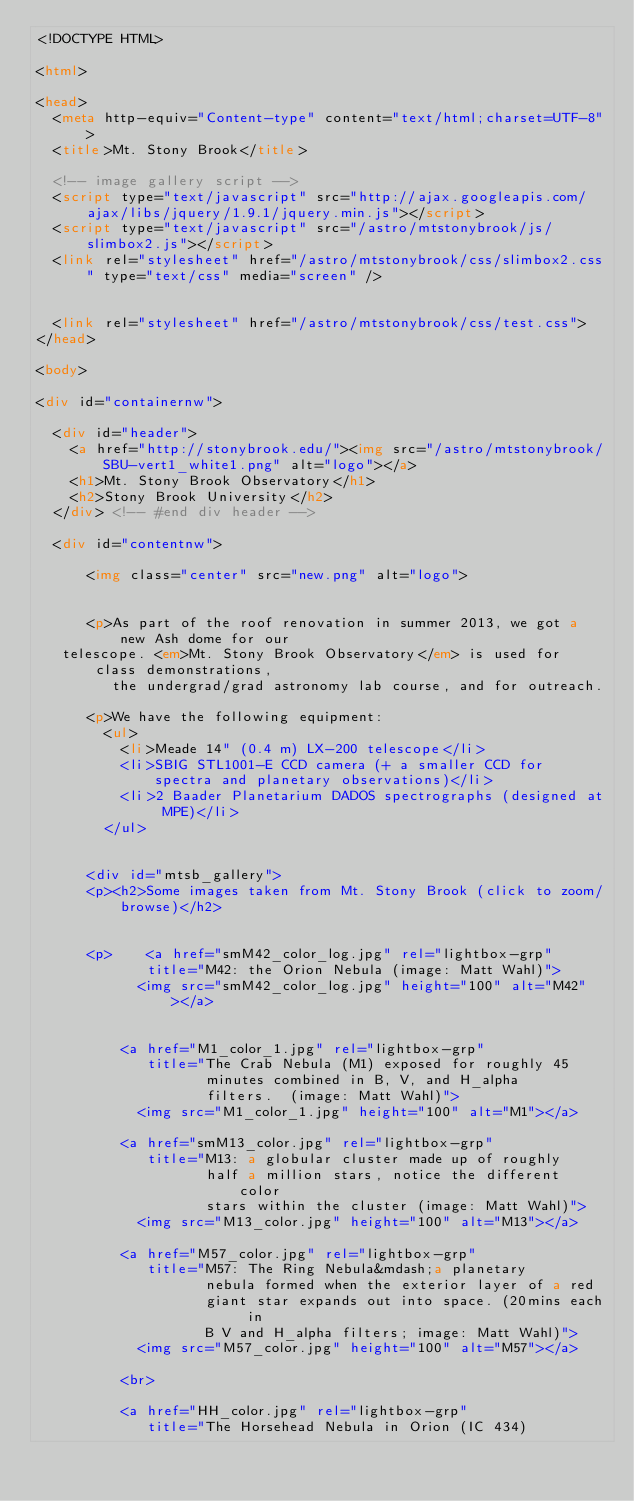Convert code to text. <code><loc_0><loc_0><loc_500><loc_500><_HTML_><!DOCTYPE HTML>

<html>

<head>
  <meta http-equiv="Content-type" content="text/html;charset=UTF-8">
  <title>Mt. Stony Brook</title>

  <!-- image gallery script -->
  <script type="text/javascript" src="http://ajax.googleapis.com/ajax/libs/jquery/1.9.1/jquery.min.js"></script>
  <script type="text/javascript" src="/astro/mtstonybrook/js/slimbox2.js"></script>
  <link rel="stylesheet" href="/astro/mtstonybrook/css/slimbox2.css" type="text/css" media="screen" />


  <link rel="stylesheet" href="/astro/mtstonybrook/css/test.css">
</head>

<body>

<div id="containernw">

  <div id="header">
    <a href="http://stonybrook.edu/"><img src="/astro/mtstonybrook/SBU-vert1_white1.png" alt="logo"></a>
    <h1>Mt. Stony Brook Observatory</h1>
    <h2>Stony Brook University</h2>
  </div> <!-- #end div header -->

  <div id="contentnw">

      <img class="center" src="new.png" alt="logo">


      <p>As part of the roof renovation in summer 2013, we got a new Ash dome for our
	 telescope. <em>Mt. Stony Brook Observatory</em> is used for class demonstrations,
         the undergrad/grad astronomy lab course, and for outreach. 

      <p>We have the following equipment:
        <ul>
          <li>Meade 14" (0.4 m) LX-200 telescope</li>
          <li>SBIG STL1001-E CCD camera (+ a smaller CCD for spectra and planetary observations)</li>
          <li>2 Baader Planetarium DADOS spectrographs (designed at MPE)</li>
        </ul>


      <div id="mtsb_gallery">
      <p><h2>Some images taken from Mt. Stony Brook (click to zoom/browse)</h2>


      <p>    <a href="smM42_color_log.jpg" rel="lightbox-grp"
             title="M42: the Orion Nebula (image: Matt Wahl)">
            <img src="smM42_color_log.jpg" height="100" alt="M42"></a>


          <a href="M1_color_1.jpg" rel="lightbox-grp"
             title="The Crab Nebula (M1) exposed for roughly 45
                    minutes combined in B, V, and H_alpha
                    filters.  (image: Matt Wahl)">
            <img src="M1_color_1.jpg" height="100" alt="M1"></a>
	  
          <a href="smM13_color.jpg" rel="lightbox-grp"
             title="M13: a globular cluster made up of roughly
                    half a million stars, notice the different color
                    stars within the cluster (image: Matt Wahl)">
            <img src="M13_color.jpg" height="100" alt="M13"></a>
	  
          <a href="M57_color.jpg" rel="lightbox-grp"
             title="M57: The Ring Nebula&mdash;a planetary
                    nebula formed when the exterior layer of a red
                    giant star expands out into space. (20mins each in
                    B V and H_alpha filters; image: Matt Wahl)">
            <img src="M57_color.jpg" height="100" alt="M57"></a>
	  
          <br>
	  
          <a href="HH_color.jpg" rel="lightbox-grp"
             title="The Horsehead Nebula in Orion (IC 434)</code> 